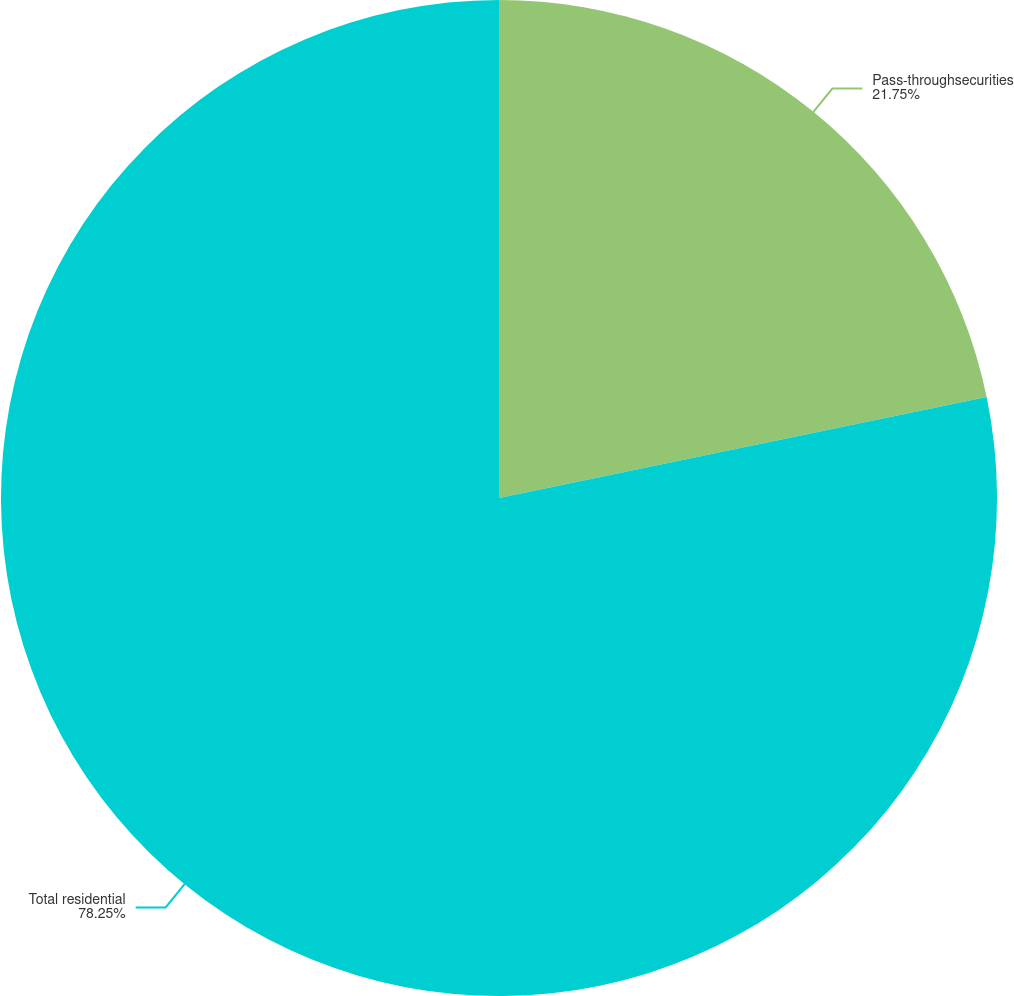<chart> <loc_0><loc_0><loc_500><loc_500><pie_chart><fcel>Pass-throughsecurities<fcel>Total residential<nl><fcel>21.75%<fcel>78.25%<nl></chart> 